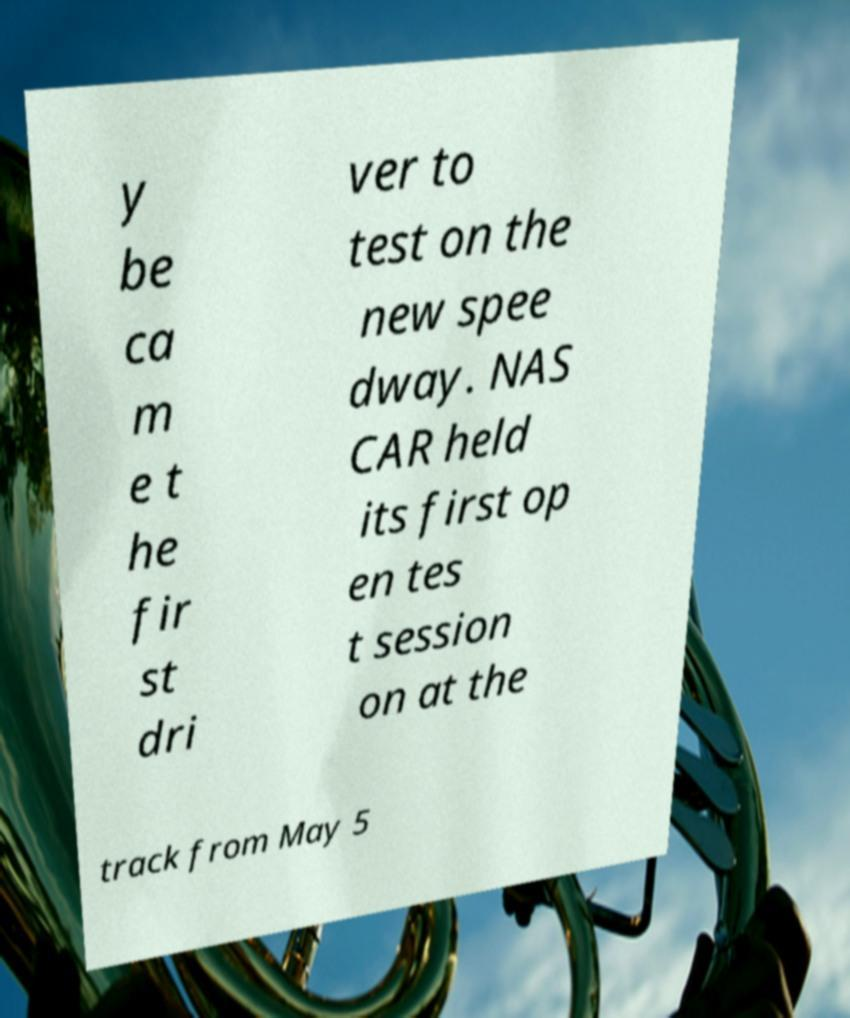For documentation purposes, I need the text within this image transcribed. Could you provide that? y be ca m e t he fir st dri ver to test on the new spee dway. NAS CAR held its first op en tes t session on at the track from May 5 